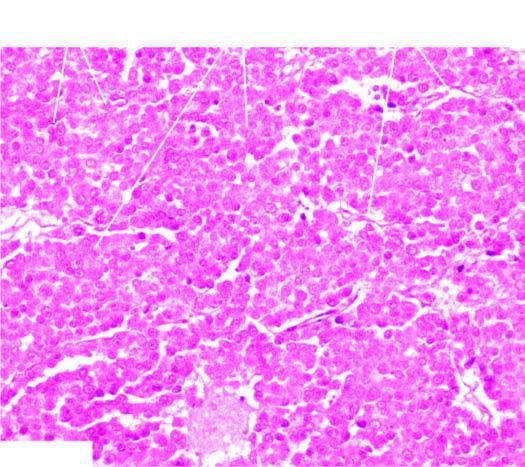s the histologic appearance identical to that of seminoma of the testis?
Answer the question using a single word or phrase. Yes 